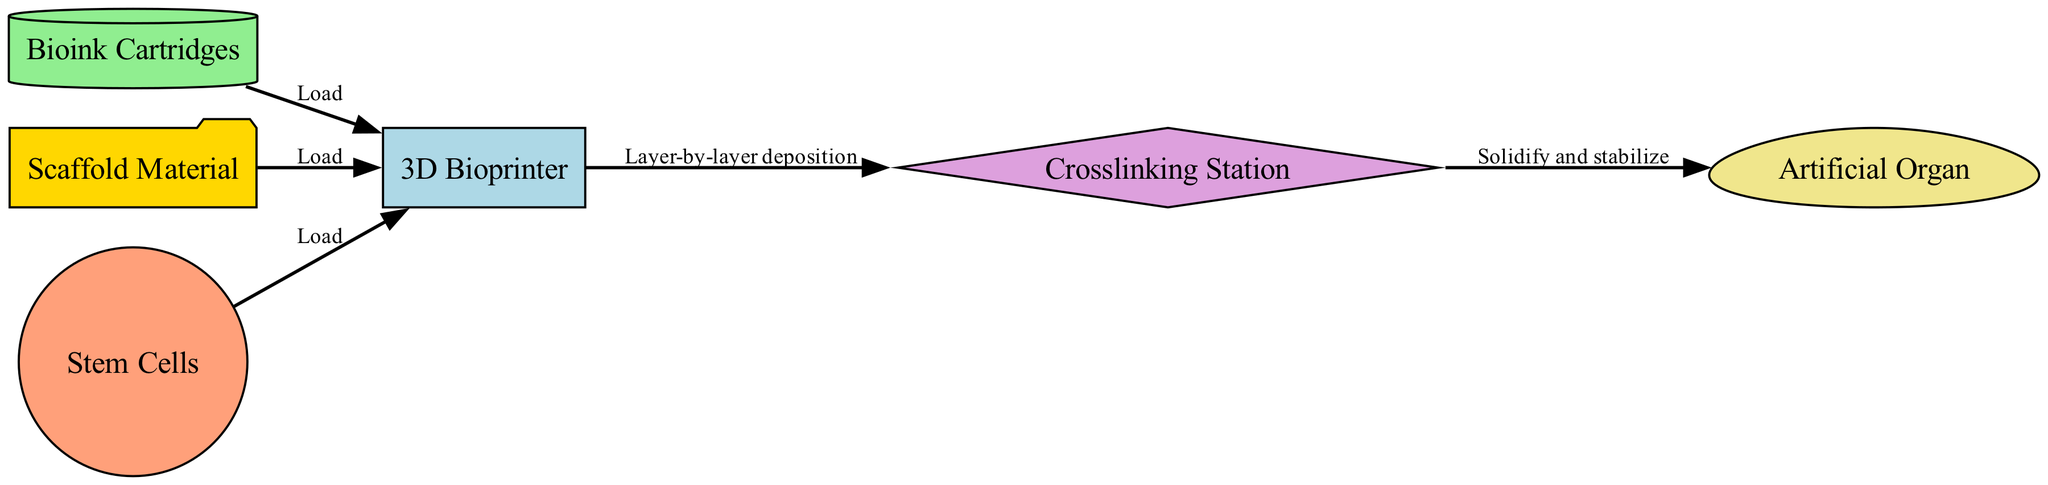What type of printer is depicted in the diagram? The diagram features a node labeled "3D Bioprinter," which indicates the type of printer being represented.
Answer: 3D Bioprinter How many nodes are present in the diagram? By counting the unique nodes listed in the diagram, we find a total of six nodes: 3D Bioprinter, Bioink Cartridges, Scaffold Material, Stem Cells, Crosslinking Station, and Artificial Organ.
Answer: 6 What is the first step involving bioink in the process? The relationship from the Bioink Cartridges to the 3D Bioprinter shows that the first step is to "Load" the bioink into the printer.
Answer: Load Which two materials are loaded into the bioprinter alongside cell types? The diagram shows that both Scaffold Material and Bioink Cartridges are also loaded into the 3D Bioprinter alongside Stem Cells.
Answer: Scaffold Material and Bioink Cartridges What is the process that occurs after the layer-by-layer deposition in the bioprinting? After the bioprinter conducts a layer-by-layer deposition, the next process depicted is "Solidify and stabilize" in the Crosslinking Station leading to the Artificial Organ.
Answer: Solidify and stabilize What connects the bioprinter to the crosslinking station? The edge labeled "Layer-by-layer deposition" directly connects the 3D Bioprinter to the Crosslinking Station, indicating the process linking these two components.
Answer: Layer-by-layer deposition What is the end product of the process depicted in the diagram? The diagram concludes with an edge from the Crosslinking Station to an endpoint labeled "Artificial Organ," indicating that this is the final product of the bioprinting process.
Answer: Artificial Organ What shape is used to represent the scaffold material? The diagram uses a "folder" shape to represent the Scaffold Material, visually distinguishing it from other components.
Answer: Folder What is the role of stem cells in the bioprinting process? Stem Cells are loaded into the 3D Bioprinter, indicating their role in being part of the bioprinting material.
Answer: Load 